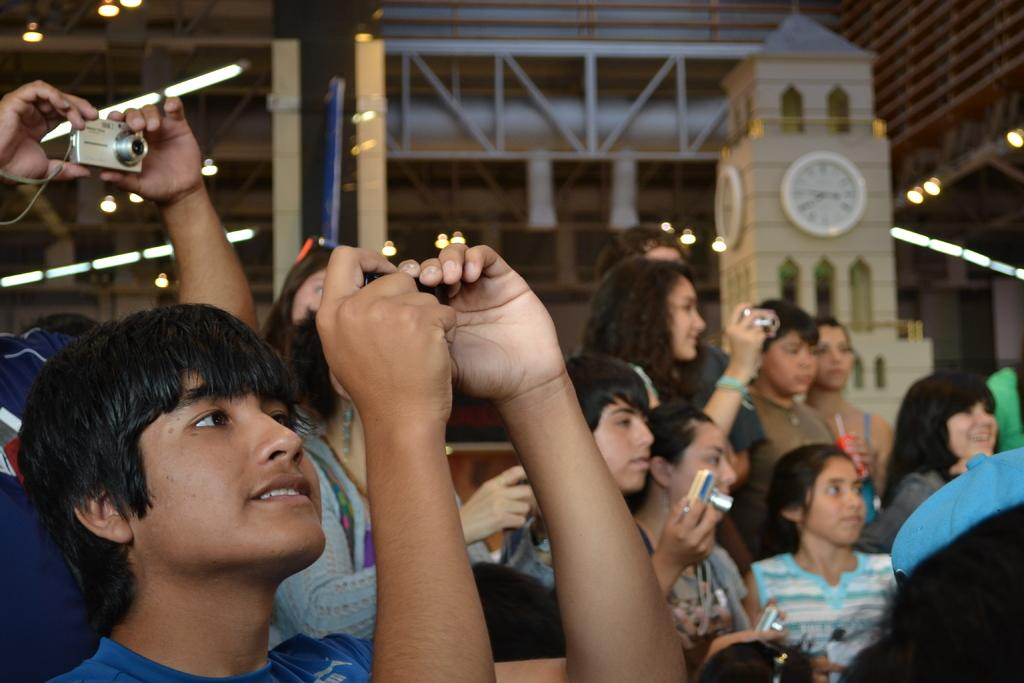What can be seen in the image? There are kids in the image. What are the kids doing? The kids are holding cameras in their hands and clicking pictures. What can be seen in the background of the image? There is a clock tower and a metal structure in the background of the image. What type of balls are the kids playing with in the image? There are no balls present in the image; the kids are holding cameras and clicking pictures. Can you describe the desk that the kids are using to take pictures from in the image? There is no desk present in the image; the kids are holding cameras in their hands. 